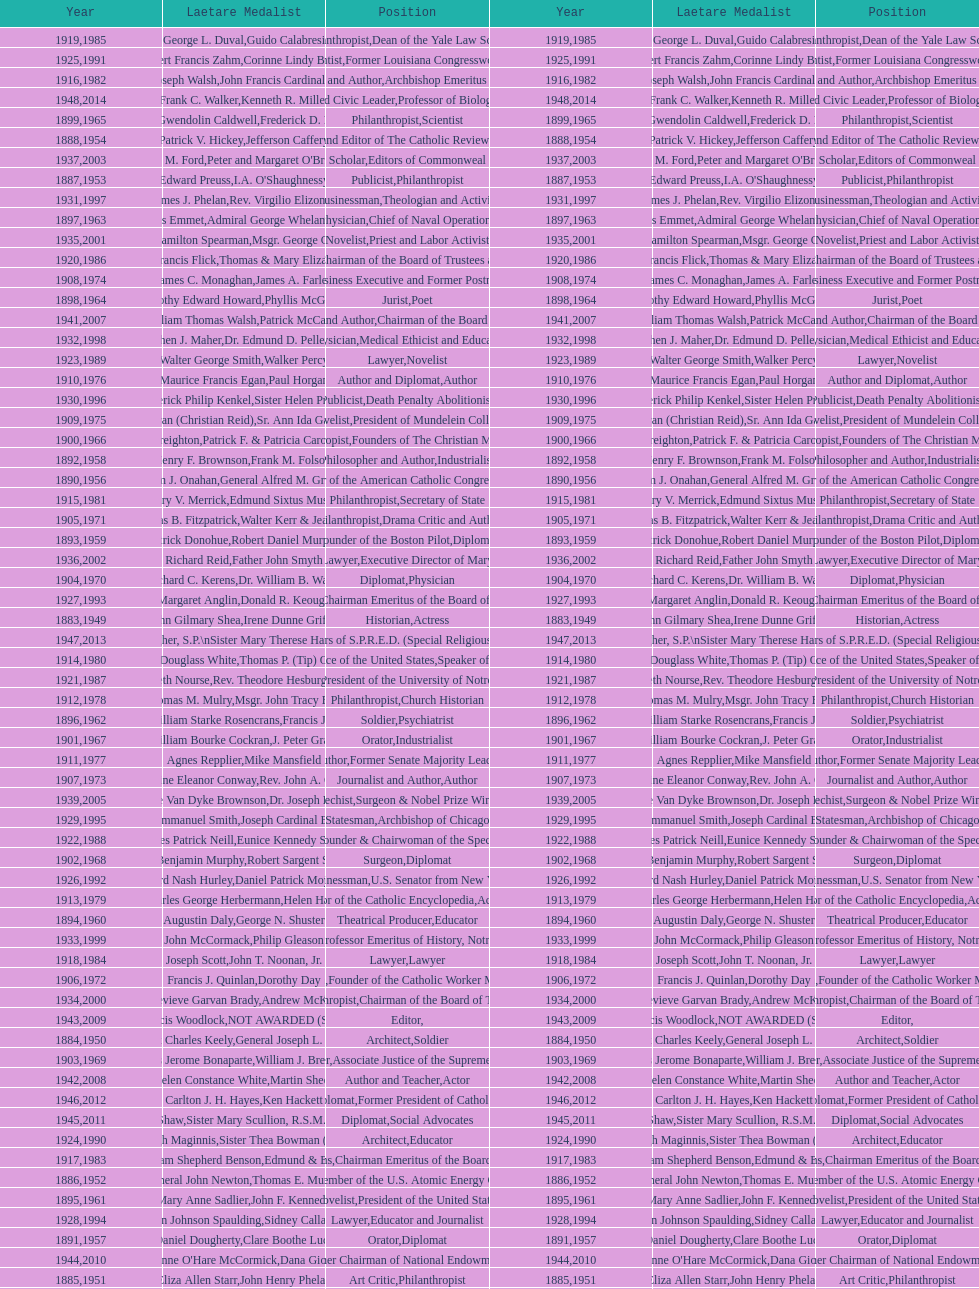What are the number of laetare medalist that held a diplomat position? 8. Would you mind parsing the complete table? {'header': ['Year', 'Laetare Medalist', 'Position', 'Year', 'Laetare Medalist', 'Position'], 'rows': [['1919', 'George L. Duval', 'Philanthropist', '1985', 'Guido Calabresi', 'Dean of the Yale Law School'], ['1925', 'Albert Francis Zahm', 'Scientist', '1991', 'Corinne Lindy Boggs', 'Former Louisiana Congresswoman'], ['1916', 'James Joseph Walsh', 'Physician and Author', '1982', 'John Francis Cardinal Dearden', 'Archbishop Emeritus of Detroit'], ['1948', 'Frank C. Walker', 'Postmaster General and Civic Leader', '2014', 'Kenneth R. Miller', 'Professor of Biology at Brown University'], ['1899', 'Mary Gwendolin Caldwell', 'Philanthropist', '1965', 'Frederick D. Rossini', 'Scientist'], ['1888', 'Patrick V. Hickey', 'Founder and Editor of The Catholic Review', '1954', 'Jefferson Caffery', 'Diplomat'], ['1937', 'Jeremiah D. M. Ford', 'Scholar', '2003', "Peter and Margaret O'Brien Steinfels", 'Editors of Commonweal'], ['1887', 'Edward Preuss', 'Publicist', '1953', "I.A. O'Shaughnessy", 'Philanthropist'], ['1931', 'James J. Phelan', 'Businessman', '1997', 'Rev. Virgilio Elizondo', 'Theologian and Activist'], ['1897', 'Thomas Addis Emmet', 'Physician', '1963', 'Admiral George Whelan Anderson, Jr.', 'Chief of Naval Operations'], ['1935', 'Francis Hamilton Spearman', 'Novelist', '2001', 'Msgr. George G. Higgins', 'Priest and Labor Activist'], ['1920', 'Lawrence Francis Flick', 'Physician', '1986', 'Thomas & Mary Elizabeth Carney', 'Chairman of the Board of Trustees and his wife'], ['1908', 'James C. Monaghan', 'Economist', '1974', 'James A. Farley', 'Business Executive and Former Postmaster General'], ['1898', 'Timothy Edward Howard', 'Jurist', '1964', 'Phyllis McGinley', 'Poet'], ['1941', 'William Thomas Walsh', 'Journalist and Author', '2007', 'Patrick McCartan', 'Chairman of the Board of Trustees'], ['1932', 'Stephen J. Maher', 'Physician', '1998', 'Dr. Edmund D. Pellegrino', 'Medical Ethicist and Educator'], ['1923', 'Walter George Smith', 'Lawyer', '1989', 'Walker Percy', 'Novelist'], ['1910', 'Maurice Francis Egan', 'Author and Diplomat', '1976', 'Paul Horgan', 'Author'], ['1930', 'Frederick Philip Kenkel', 'Publicist', '1996', 'Sister Helen Prejean', 'Death Penalty Abolitionist'], ['1909', 'Frances Tieran (Christian Reid)', 'Novelist', '1975', 'Sr. Ann Ida Gannon, BMV', 'President of Mundelein College'], ['1900', 'John A. Creighton', 'Philanthropist', '1966', 'Patrick F. & Patricia Caron Crowley', 'Founders of The Christian Movement'], ['1892', 'Henry F. Brownson', 'Philosopher and Author', '1958', 'Frank M. Folsom', 'Industrialist'], ['1890', 'William J. Onahan', 'Organizer of the American Catholic Congress', '1956', 'General Alfred M. Gruenther', 'Soldier'], ['1915', 'Mary V. Merrick', 'Philanthropist', '1981', 'Edmund Sixtus Muskie', 'Secretary of State'], ['1905', 'Thomas B. Fitzpatrick', 'Philanthropist', '1971', 'Walter Kerr & Jean Kerr', 'Drama Critic and Author'], ['1893', 'Patrick Donohue', 'Founder of the Boston Pilot', '1959', 'Robert Daniel Murphy', 'Diplomat'], ['1936', 'Richard Reid', 'Journalist and Lawyer', '2002', 'Father John Smyth', 'Executive Director of Maryville Academy'], ['1904', 'Richard C. Kerens', 'Diplomat', '1970', 'Dr. William B. Walsh', 'Physician'], ['1927', 'Margaret Anglin', 'Actress', '1993', 'Donald R. Keough', 'Chairman Emeritus of the Board of Trustees'], ['1883', 'John Gilmary Shea', 'Historian', '1949', 'Irene Dunne Griffin', 'Actress'], ['1947', 'William G. Bruce', 'Publisher and Civic Leader', '2013', 'Sister Susanne Gallagher, S.P.\\nSister Mary Therese Harrington, S.H.\\nRev. James H. McCarthy', 'Founders of S.P.R.E.D. (Special Religious Education Development Network)'], ['1914', 'Edward Douglass White', 'Chief Justice of the United States', '1980', "Thomas P. (Tip) O'Neill Jr.", 'Speaker of the House'], ['1921', 'Elizabeth Nourse', 'Artist', '1987', 'Rev. Theodore Hesburgh, CSC', 'President of the University of Notre Dame'], ['1912', 'Thomas M. Mulry', 'Philanthropist', '1978', 'Msgr. John Tracy Ellis', 'Church Historian'], ['1896', 'General William Starke Rosencrans', 'Soldier', '1962', 'Francis J. Braceland', 'Psychiatrist'], ['1901', 'William Bourke Cockran', 'Orator', '1967', 'J. Peter Grace', 'Industrialist'], ['1911', 'Agnes Repplier', 'Author', '1977', 'Mike Mansfield', 'Former Senate Majority Leader'], ['1907', 'Katherine Eleanor Conway', 'Journalist and Author', '1973', "Rev. John A. O'Brien", 'Author'], ['1939', 'Josephine Van Dyke Brownson', 'Catechist', '2005', 'Dr. Joseph E. Murray', 'Surgeon & Nobel Prize Winner'], ['1929', 'Alfred Emmanuel Smith', 'Statesman', '1995', 'Joseph Cardinal Bernardin', 'Archbishop of Chicago'], ['1922', 'Charles Patrick Neill', 'Economist', '1988', 'Eunice Kennedy Shriver', 'Founder & Chairwoman of the Special Olympics'], ['1902', 'John Benjamin Murphy', 'Surgeon', '1968', 'Robert Sargent Shriver', 'Diplomat'], ['1926', 'Edward Nash Hurley', 'Businessman', '1992', 'Daniel Patrick Moynihan', 'U.S. Senator from New York'], ['1913', 'Charles George Herbermann', 'Editor of the Catholic Encyclopedia', '1979', 'Helen Hayes', 'Actress'], ['1894', 'Augustin Daly', 'Theatrical Producer', '1960', 'George N. Shuster', 'Educator'], ['1933', 'John McCormack', 'Artist', '1999', 'Philip Gleason', 'Professor Emeritus of History, Notre Dame'], ['1918', 'Joseph Scott', 'Lawyer', '1984', 'John T. Noonan, Jr.', 'Lawyer'], ['1906', 'Francis J. Quinlan', 'Physician', '1972', 'Dorothy Day', 'Founder of the Catholic Worker Movement'], ['1934', 'Genevieve Garvan Brady', 'Philanthropist', '2000', 'Andrew McKenna', 'Chairman of the Board of Trustees'], ['1943', 'Thomas Francis Woodlock', 'Editor', '2009', 'NOT AWARDED (SEE BELOW)', ''], ['1884', 'Patrick Charles Keely', 'Architect', '1950', 'General Joseph L. Collins', 'Soldier'], ['1903', 'Charles Jerome Bonaparte', 'Lawyer', '1969', 'William J. Brennan Jr.', 'Associate Justice of the Supreme Court'], ['1942', 'Helen Constance White', 'Author and Teacher', '2008', 'Martin Sheen', 'Actor'], ['1946', 'Carlton J. H. Hayes', 'Historian and Diplomat', '2012', 'Ken Hackett', 'Former President of Catholic Relief Services'], ['1945', 'Gardiner Howland Shaw', 'Diplomat', '2011', 'Sister Mary Scullion, R.S.M., & Joan McConnon', 'Social Advocates'], ['1924', 'Charles Donagh Maginnis', 'Architect', '1990', 'Sister Thea Bowman (posthumously)', 'Educator'], ['1917', 'Admiral William Shepherd Benson', 'Chief of Naval Operations', '1983', 'Edmund & Evelyn Stephan', 'Chairman Emeritus of the Board of Trustees and his wife'], ['1886', 'General John Newton', 'Engineer', '1952', 'Thomas E. Murray', 'Member of the U.S. Atomic Energy Commission'], ['1895', 'Mary Anne Sadlier', 'Novelist', '1961', 'John F. Kennedy', 'President of the United States'], ['1928', 'John Johnson Spaulding', 'Lawyer', '1994', 'Sidney Callahan', 'Educator and Journalist'], ['1891', 'Daniel Dougherty', 'Orator', '1957', 'Clare Boothe Luce', 'Diplomat'], ['1944', "Anne O'Hare McCormick", 'Journalist', '2010', 'Dana Gioia', 'Former Chairman of National Endowment for the Arts'], ['1885', 'Eliza Allen Starr', 'Art Critic', '1951', 'John Henry Phelan', 'Philanthropist'], ['1938', 'Irvin William Abell', 'Surgeon', '2004', 'Father J. Bryan Hehir', 'President of Catholic Charities, Archdiocese of Boston'], ['1889', 'Anna Hanson Dorsey', 'Novelist', '1955', 'George Meany', 'Labor Leader'], ['1940', 'General Hugh Aloysius Drum', 'Soldier', '2006', 'Dave Brubeck', 'Jazz Pianist']]} 